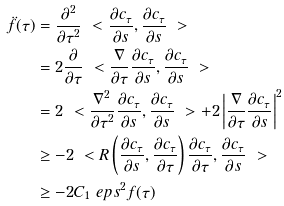Convert formula to latex. <formula><loc_0><loc_0><loc_500><loc_500>\ddot { f } ( \tau ) & = \frac { \partial ^ { 2 } } { \partial \tau ^ { 2 } } \ < \frac { \partial c _ { \tau } } { \partial s } , \frac { \partial c _ { \tau } } { \partial s } \ > \\ & = 2 \frac { \partial } { \partial \tau } \ < \frac { \nabla } { \partial \tau } \frac { \partial c _ { \tau } } { \partial s } , \frac { \partial c _ { \tau } } { \partial s } \ > \\ & = 2 \ < \frac { \nabla ^ { 2 } } { \partial \tau ^ { 2 } } \frac { \partial c _ { \tau } } { \partial s } , \frac { \partial c _ { \tau } } { \partial s } \ > + 2 \left | \frac { \nabla } { \partial \tau } \frac { \partial c _ { \tau } } { \partial s } \right | ^ { 2 } \\ & \geq - 2 \ < R \left ( \frac { \partial c _ { \tau } } { \partial s } , \frac { \partial c _ { \tau } } { \partial \tau } \right ) \frac { \partial c _ { \tau } } { \partial \tau } , \frac { \partial c _ { \tau } } { \partial s } \ > \\ & \geq - 2 C _ { 1 } \ e p s ^ { 2 } f ( \tau )</formula> 